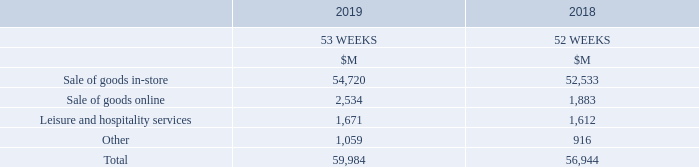The Group’s revenue mainly comprises the sale of goods in-store and online, and hospitality and leisure services. Revenue is recognised when control of the goods has transferred to the customer or when the service is provided at an amount that reflects the consideration to which the Group expects to be entitled.
For sale of goods in-store, control of the goods transfers to the customer at the point the customer purchases the goods in-store. For sale of goods online, control of the goods transfers to the customer at the point the goods are delivered to, or collected by, the customer. Where payment for the goods is received prior to control transferring to the customer, revenue recognition is deferred in contract liabilities within trade and other payables in the Consolidated Statement of Financial Position until the goods have been delivered to, or collected by, the customer.
Woolworths Rewards points granted by the Group provide customers with a material right to a discount on future purchases. The amounts allocated to Woolworths Rewards points are deferred in contract liabilities within trade and other payables in the Consolidated Statement of Financial Position until redeemed by the customer.
What is The Group's revenue mainly made up of? The group’s revenue mainly comprises the sale of goods in-store and online, and hospitality and leisure services. What is the sale of goods in-store in 2019?
Answer scale should be: million. 54,720. What can customers do with the Woolworths Rewards points earned in the Loyalty program? Woolworths rewards points granted by the group provide customers with a material right to a discount on future purchases. What is the average sale of goods in-store for both 2018 and 2019?
Answer scale should be: million. (54,720 + 52,533)/2 
Answer: 53626.5. What is the difference in value for sale of goods online between 2019 and 2018?
Answer scale should be: million. 2,534 - 1,883 
Answer: 651. What proportion does leisure and hospitality services constitute in the total revenue in 2019?
Answer scale should be: percent. 1,671/59,984 
Answer: 2.79. 